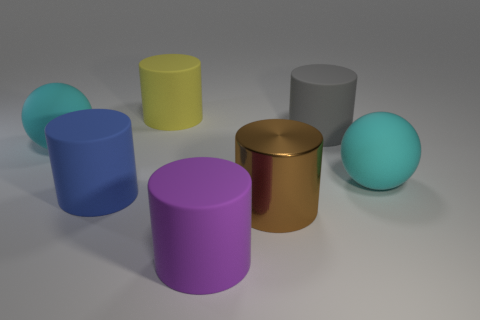Subtract 1 cylinders. How many cylinders are left? 4 Subtract all brown cylinders. How many cylinders are left? 4 Subtract all brown cylinders. How many cylinders are left? 4 Subtract all cyan cylinders. Subtract all brown blocks. How many cylinders are left? 5 Add 1 purple cylinders. How many objects exist? 8 Subtract all cylinders. How many objects are left? 2 Add 1 rubber cylinders. How many rubber cylinders are left? 5 Add 7 big shiny things. How many big shiny things exist? 8 Subtract 1 blue cylinders. How many objects are left? 6 Subtract all tiny gray shiny things. Subtract all purple things. How many objects are left? 6 